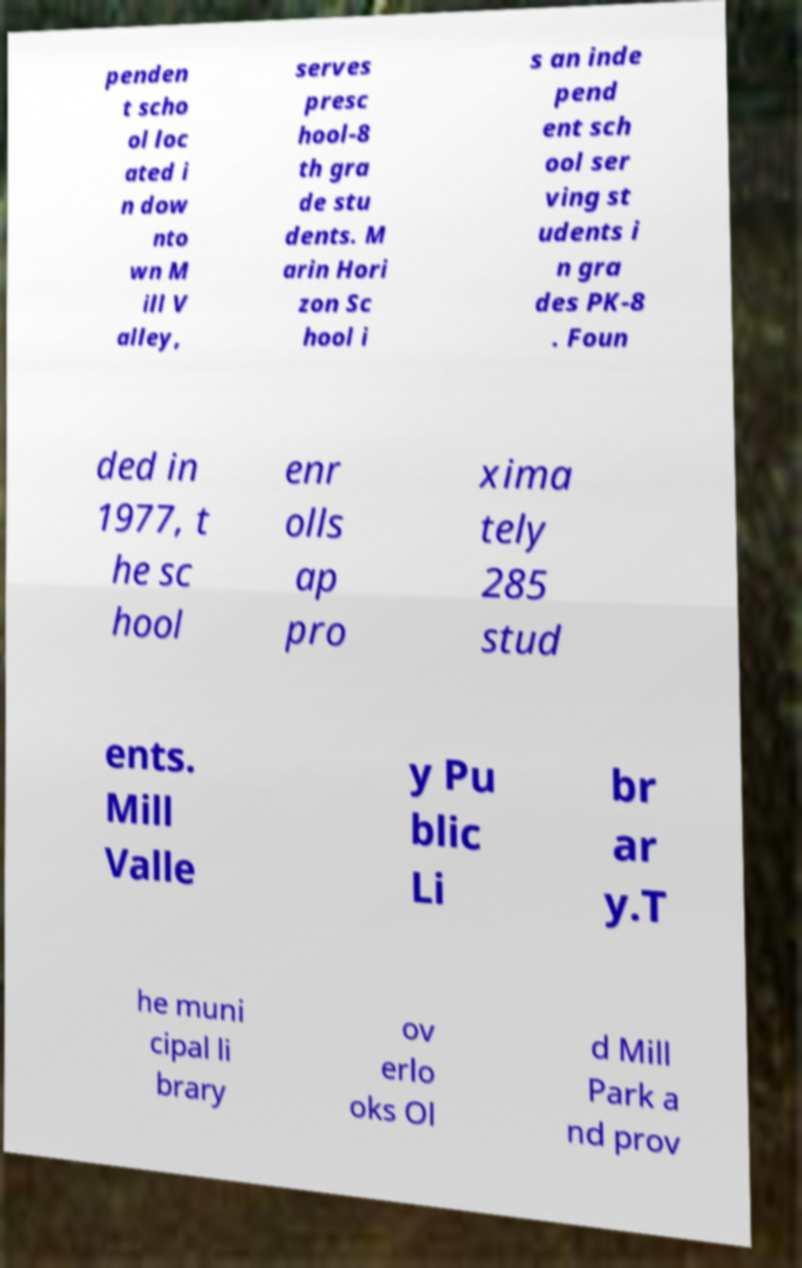Could you assist in decoding the text presented in this image and type it out clearly? penden t scho ol loc ated i n dow nto wn M ill V alley, serves presc hool-8 th gra de stu dents. M arin Hori zon Sc hool i s an inde pend ent sch ool ser ving st udents i n gra des PK-8 . Foun ded in 1977, t he sc hool enr olls ap pro xima tely 285 stud ents. Mill Valle y Pu blic Li br ar y.T he muni cipal li brary ov erlo oks Ol d Mill Park a nd prov 